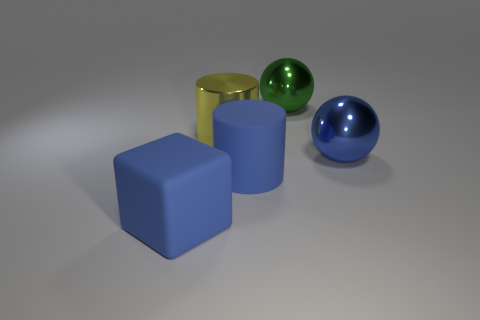Is the material of the large blue cylinder the same as the large blue thing that is in front of the rubber cylinder?
Your response must be concise. Yes. What number of small things are either cyan metal cylinders or green metallic things?
Your answer should be compact. 0. What is the material of the big sphere that is the same color as the rubber cube?
Provide a succinct answer. Metal. Are there fewer small green cylinders than green metallic objects?
Make the answer very short. Yes. Does the matte thing that is behind the large blue block have the same size as the metal ball that is behind the large blue sphere?
Your answer should be compact. Yes. What number of blue objects are metallic spheres or matte things?
Provide a succinct answer. 3. What is the size of the ball that is the same color as the rubber cylinder?
Your answer should be compact. Large. Is the number of big yellow metallic spheres greater than the number of large yellow things?
Keep it short and to the point. No. Do the matte block and the big matte cylinder have the same color?
Your response must be concise. Yes. What number of objects are either yellow cylinders or large things that are behind the blue matte block?
Your answer should be very brief. 4. 